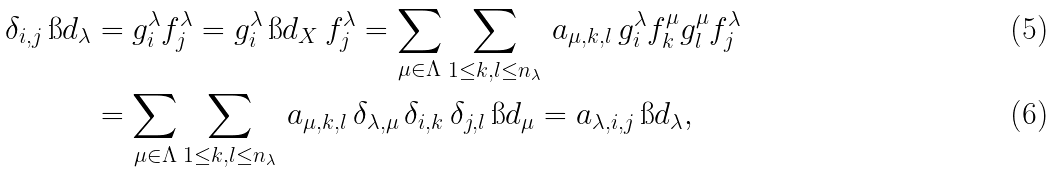<formula> <loc_0><loc_0><loc_500><loc_500>\delta _ { i , j } \, \i d _ { \lambda } & = g _ { i } ^ { \lambda } f _ { j } ^ { \lambda } = g _ { i } ^ { \lambda } \, \i d _ { X } \, f _ { j } ^ { \lambda } = \sum _ { \mu \in \Lambda } \sum _ { 1 \leq k , l \leq n _ { \lambda } } \, a _ { \mu , k , l } \, g _ { i } ^ { \lambda } f _ { k } ^ { \mu } g _ { l } ^ { \mu } f _ { j } ^ { \lambda } \\ & = \sum _ { \mu \in \Lambda } \sum _ { 1 \leq k , l \leq n _ { \lambda } } \, a _ { \mu , k , l } \, \delta _ { \lambda , \mu } \, \delta _ { i , k } \, \delta _ { j , l } \, \i d _ { \mu } = a _ { \lambda , i , j } \, \i d _ { \lambda } ,</formula> 